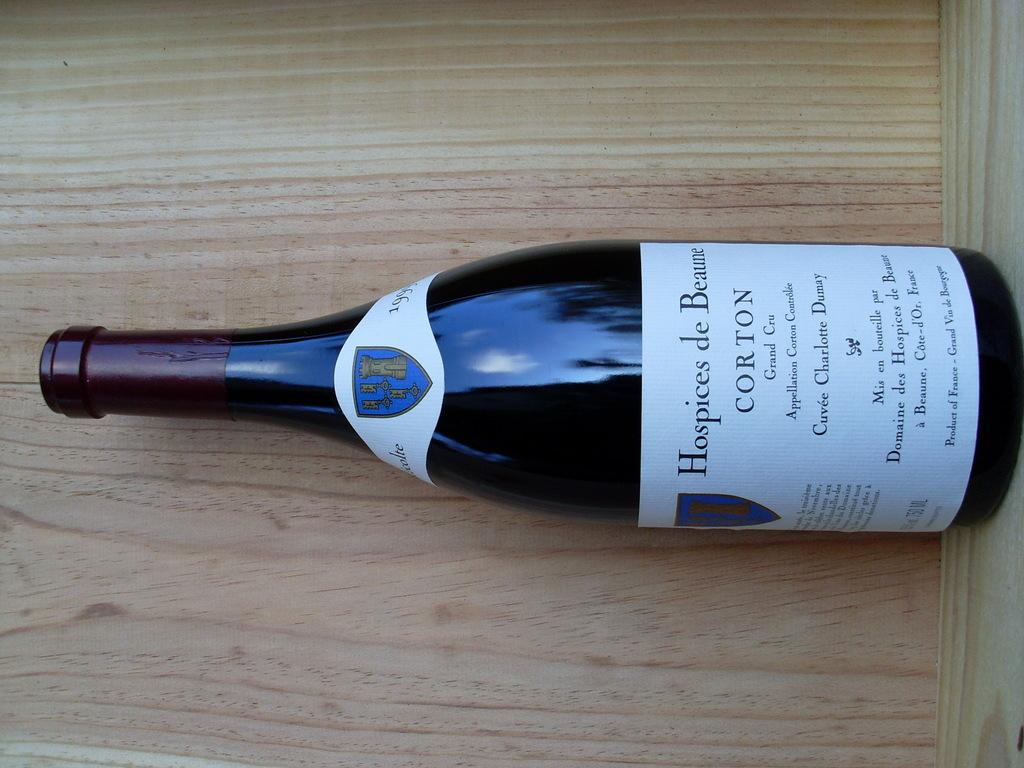<image>
Summarize the visual content of the image. A bottle of wine with the label Corton, lying on its side. 